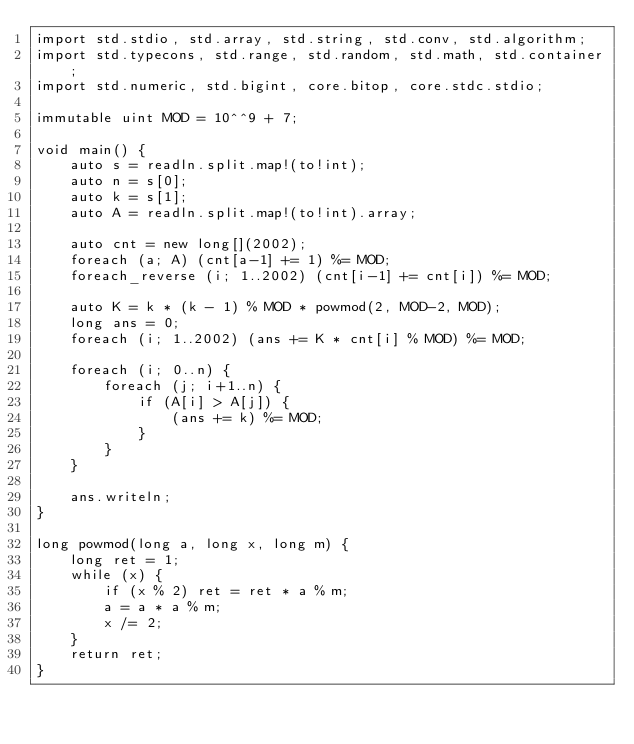<code> <loc_0><loc_0><loc_500><loc_500><_D_>import std.stdio, std.array, std.string, std.conv, std.algorithm;
import std.typecons, std.range, std.random, std.math, std.container;
import std.numeric, std.bigint, core.bitop, core.stdc.stdio;

immutable uint MOD = 10^^9 + 7;

void main() {
    auto s = readln.split.map!(to!int);
    auto n = s[0];
    auto k = s[1];
    auto A = readln.split.map!(to!int).array;

    auto cnt = new long[](2002);
    foreach (a; A) (cnt[a-1] += 1) %= MOD;
    foreach_reverse (i; 1..2002) (cnt[i-1] += cnt[i]) %= MOD;

    auto K = k * (k - 1) % MOD * powmod(2, MOD-2, MOD);
    long ans = 0;
    foreach (i; 1..2002) (ans += K * cnt[i] % MOD) %= MOD;

    foreach (i; 0..n) {
        foreach (j; i+1..n) {
            if (A[i] > A[j]) {
                (ans += k) %= MOD;
            }
        }
    }

    ans.writeln;
}

long powmod(long a, long x, long m) {
    long ret = 1;
    while (x) {
        if (x % 2) ret = ret * a % m;
        a = a * a % m;
        x /= 2;
    }
    return ret;
}
</code> 